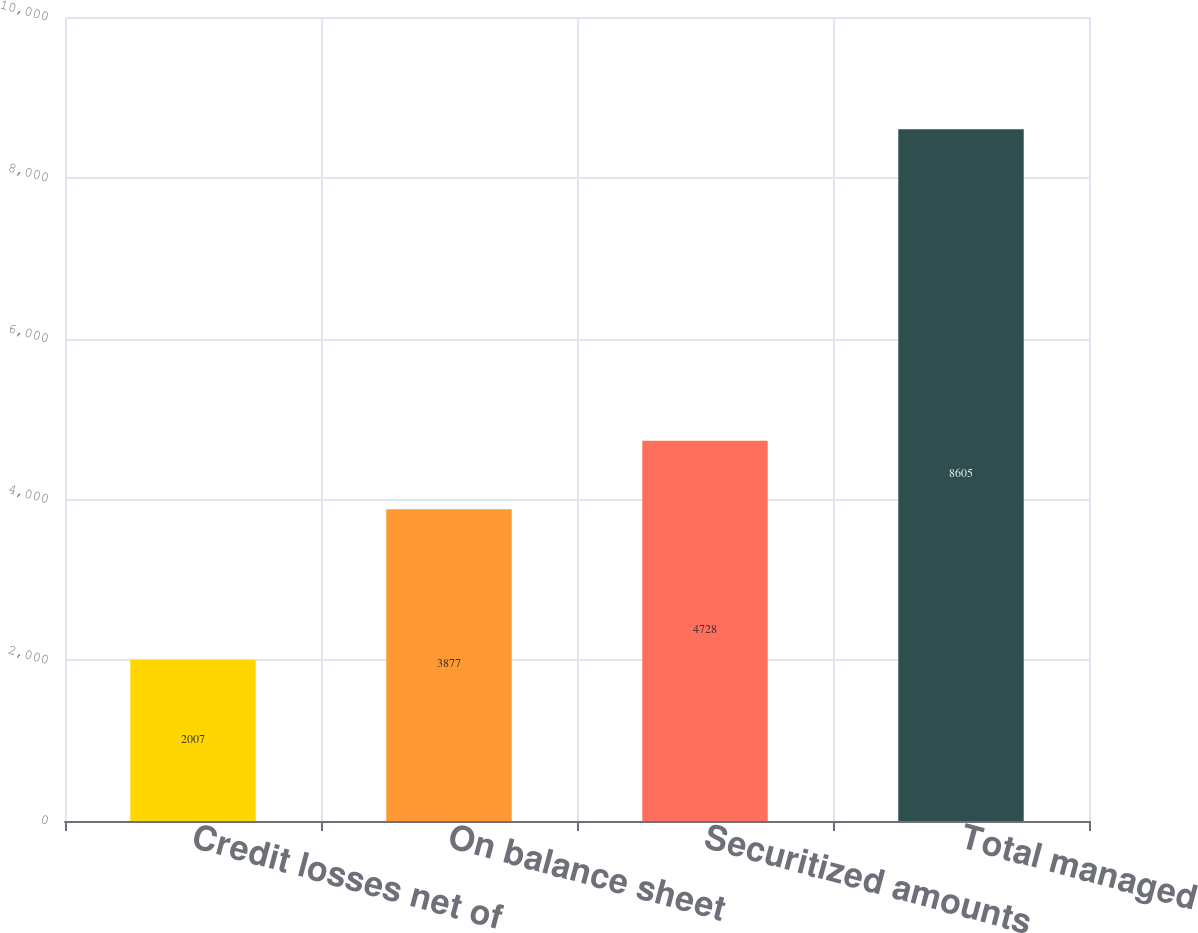Convert chart to OTSL. <chart><loc_0><loc_0><loc_500><loc_500><bar_chart><fcel>Credit losses net of<fcel>On balance sheet<fcel>Securitized amounts<fcel>Total managed<nl><fcel>2007<fcel>3877<fcel>4728<fcel>8605<nl></chart> 